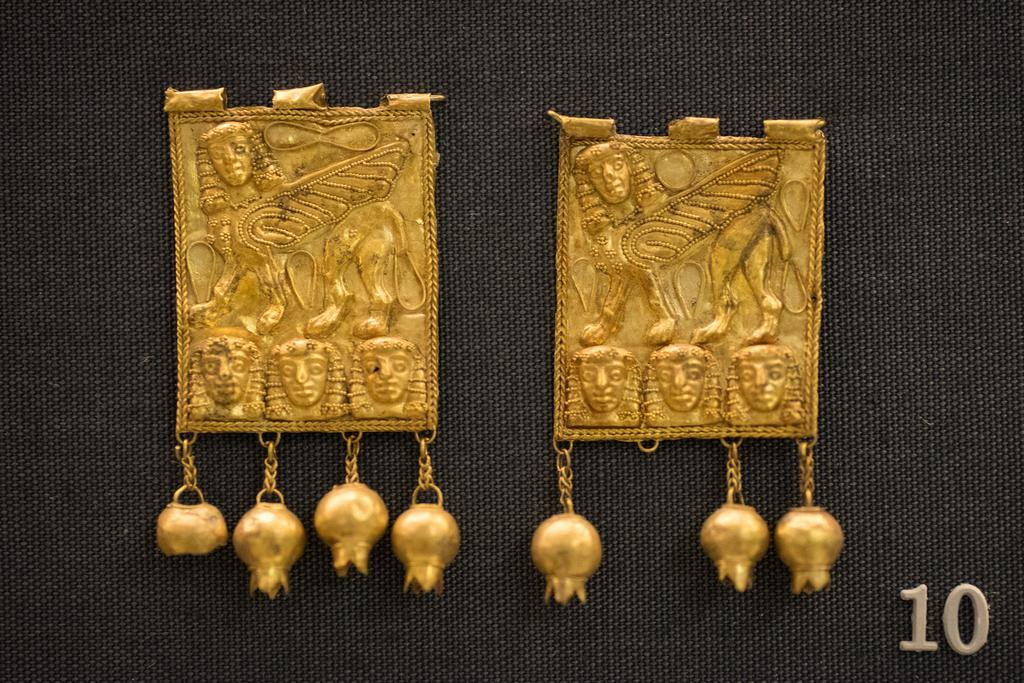What are the two objects in the image that resemble ornaments? There are two objects in the image that resemble ornaments, but their specific appearance cannot be determined from the provided facts. Where is the number located in the image? The number is visible in the bottom right side of the image. What type of fruit is being suggested by the ornaments in the image? There is no fruit present in the image, and the ornaments do not suggest any specific fruit. 